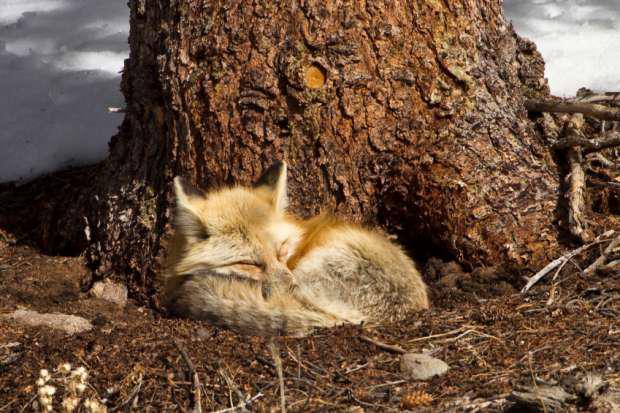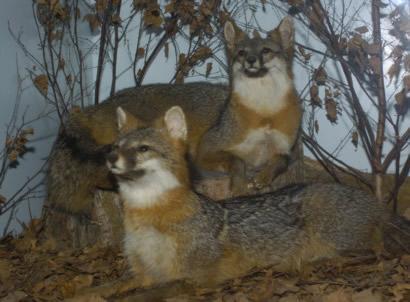The first image is the image on the left, the second image is the image on the right. Given the left and right images, does the statement "The left image features one fox in a curled resting pose, and the right image features two foxes, with one reclining on the flat surface of a cut log section." hold true? Answer yes or no. Yes. The first image is the image on the left, the second image is the image on the right. Examine the images to the left and right. Is the description "There are two foxes in the image to the right, and one in the other image." accurate? Answer yes or no. Yes. 